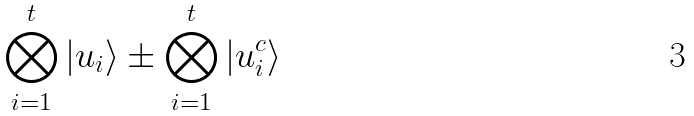<formula> <loc_0><loc_0><loc_500><loc_500>\bigotimes ^ { t } _ { i = 1 } { \left | { u _ { i } } \right \rangle } \pm \bigotimes ^ { t } _ { i = 1 } { \left | { u ^ { c } _ { i } } \right \rangle }</formula> 